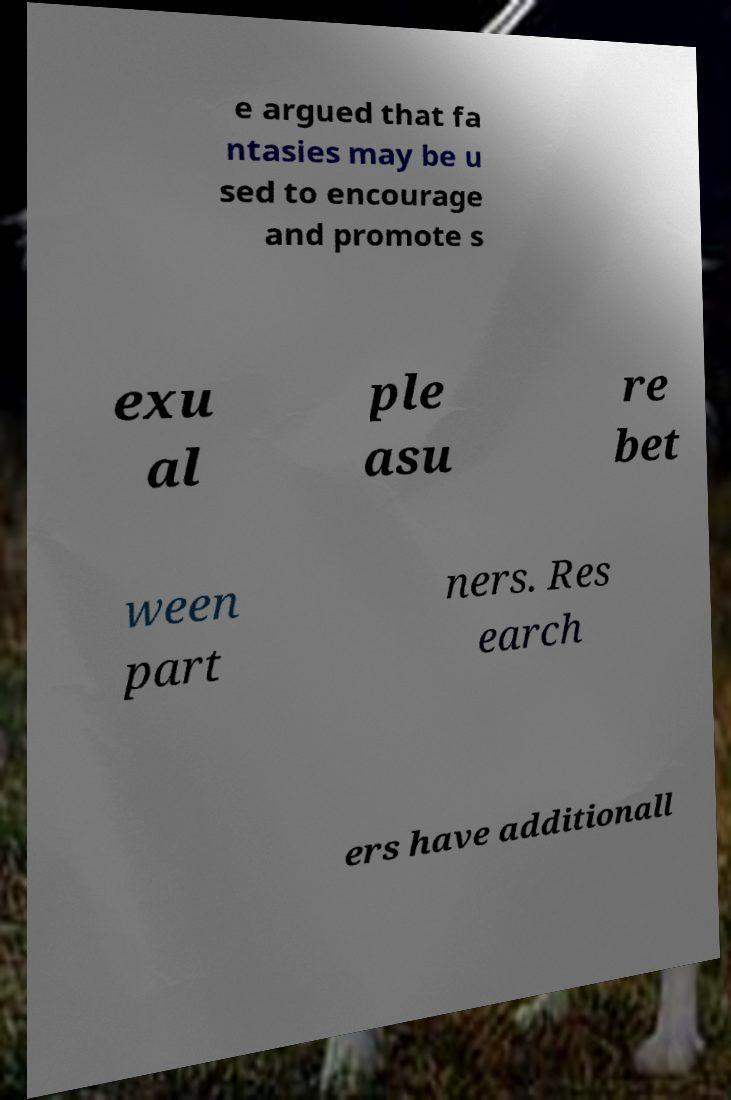I need the written content from this picture converted into text. Can you do that? e argued that fa ntasies may be u sed to encourage and promote s exu al ple asu re bet ween part ners. Res earch ers have additionall 